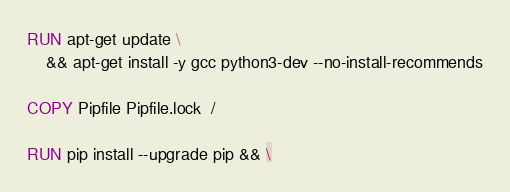Convert code to text. <code><loc_0><loc_0><loc_500><loc_500><_Dockerfile_>
RUN apt-get update \
    && apt-get install -y gcc python3-dev --no-install-recommends

COPY Pipfile Pipfile.lock  /

RUN pip install --upgrade pip && \</code> 